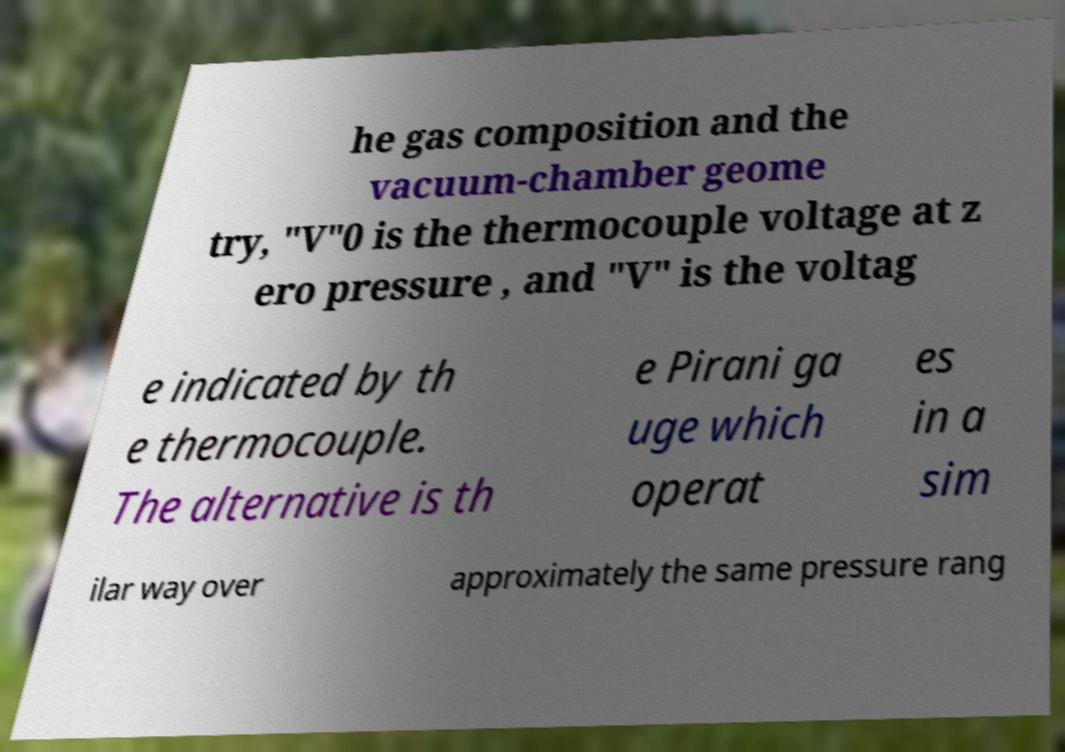For documentation purposes, I need the text within this image transcribed. Could you provide that? he gas composition and the vacuum-chamber geome try, "V"0 is the thermocouple voltage at z ero pressure , and "V" is the voltag e indicated by th e thermocouple. The alternative is th e Pirani ga uge which operat es in a sim ilar way over approximately the same pressure rang 